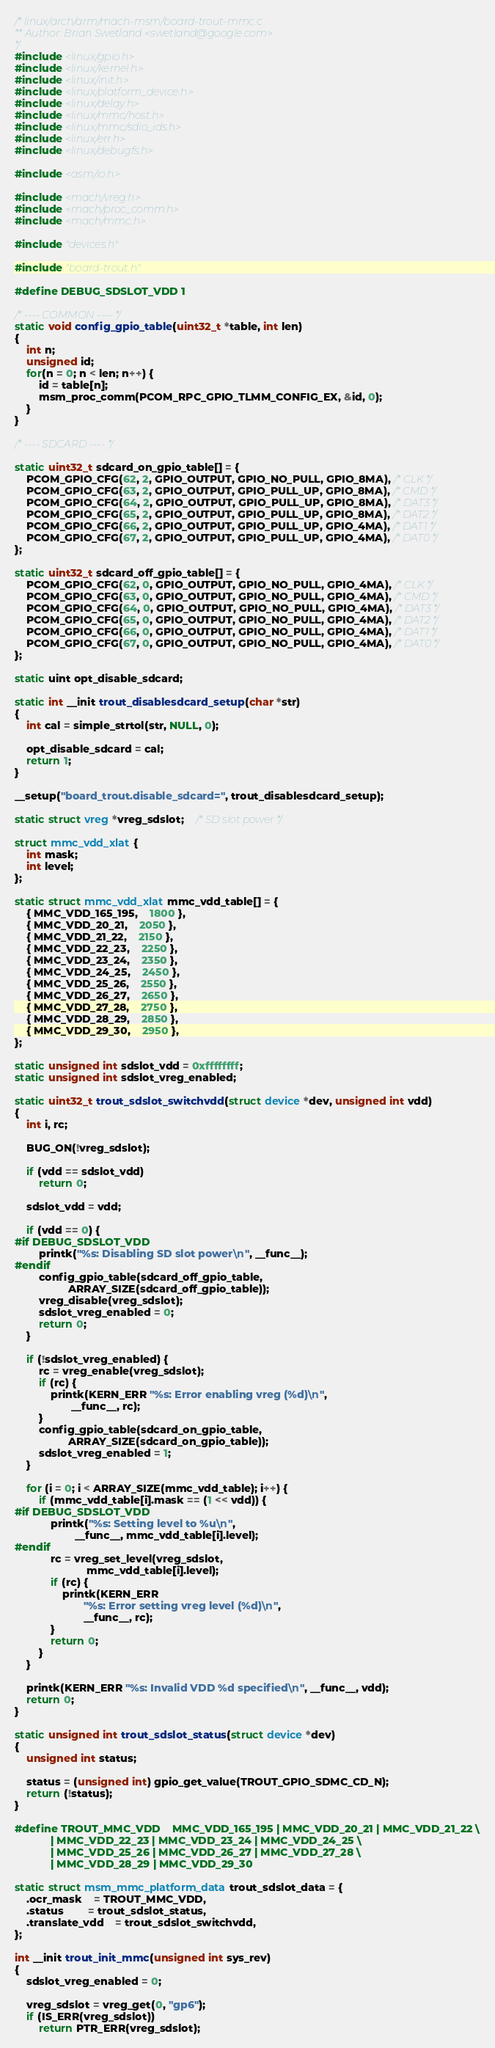Convert code to text. <code><loc_0><loc_0><loc_500><loc_500><_C_>/* linux/arch/arm/mach-msm/board-trout-mmc.c
** Author: Brian Swetland <swetland@google.com>
*/
#include <linux/gpio.h>
#include <linux/kernel.h>
#include <linux/init.h>
#include <linux/platform_device.h>
#include <linux/delay.h>
#include <linux/mmc/host.h>
#include <linux/mmc/sdio_ids.h>
#include <linux/err.h>
#include <linux/debugfs.h>

#include <asm/io.h>

#include <mach/vreg.h>
#include <mach/proc_comm.h>
#include <mach/mmc.h>

#include "devices.h"

#include "board-trout.h"

#define DEBUG_SDSLOT_VDD 1

/* ---- COMMON ---- */
static void config_gpio_table(uint32_t *table, int len)
{
	int n;
	unsigned id;
	for(n = 0; n < len; n++) {
		id = table[n];
		msm_proc_comm(PCOM_RPC_GPIO_TLMM_CONFIG_EX, &id, 0);
	}
}

/* ---- SDCARD ---- */

static uint32_t sdcard_on_gpio_table[] = {
	PCOM_GPIO_CFG(62, 2, GPIO_OUTPUT, GPIO_NO_PULL, GPIO_8MA), /* CLK */
	PCOM_GPIO_CFG(63, 2, GPIO_OUTPUT, GPIO_PULL_UP, GPIO_8MA), /* CMD */
	PCOM_GPIO_CFG(64, 2, GPIO_OUTPUT, GPIO_PULL_UP, GPIO_8MA), /* DAT3 */
	PCOM_GPIO_CFG(65, 2, GPIO_OUTPUT, GPIO_PULL_UP, GPIO_8MA), /* DAT2 */
	PCOM_GPIO_CFG(66, 2, GPIO_OUTPUT, GPIO_PULL_UP, GPIO_4MA), /* DAT1 */
	PCOM_GPIO_CFG(67, 2, GPIO_OUTPUT, GPIO_PULL_UP, GPIO_4MA), /* DAT0 */
};

static uint32_t sdcard_off_gpio_table[] = {
	PCOM_GPIO_CFG(62, 0, GPIO_OUTPUT, GPIO_NO_PULL, GPIO_4MA), /* CLK */
	PCOM_GPIO_CFG(63, 0, GPIO_OUTPUT, GPIO_NO_PULL, GPIO_4MA), /* CMD */
	PCOM_GPIO_CFG(64, 0, GPIO_OUTPUT, GPIO_NO_PULL, GPIO_4MA), /* DAT3 */
	PCOM_GPIO_CFG(65, 0, GPIO_OUTPUT, GPIO_NO_PULL, GPIO_4MA), /* DAT2 */
	PCOM_GPIO_CFG(66, 0, GPIO_OUTPUT, GPIO_NO_PULL, GPIO_4MA), /* DAT1 */
	PCOM_GPIO_CFG(67, 0, GPIO_OUTPUT, GPIO_NO_PULL, GPIO_4MA), /* DAT0 */
};

static uint opt_disable_sdcard;

static int __init trout_disablesdcard_setup(char *str)
{
	int cal = simple_strtol(str, NULL, 0);
	
	opt_disable_sdcard = cal;
	return 1;
}

__setup("board_trout.disable_sdcard=", trout_disablesdcard_setup);

static struct vreg *vreg_sdslot;	/* SD slot power */

struct mmc_vdd_xlat {
	int mask;
	int level;
};

static struct mmc_vdd_xlat mmc_vdd_table[] = {
	{ MMC_VDD_165_195,	1800 },
	{ MMC_VDD_20_21,	2050 },
	{ MMC_VDD_21_22,	2150 },
	{ MMC_VDD_22_23,	2250 },
	{ MMC_VDD_23_24,	2350 },
	{ MMC_VDD_24_25,	2450 },
	{ MMC_VDD_25_26,	2550 },
	{ MMC_VDD_26_27,	2650 },
	{ MMC_VDD_27_28,	2750 },
	{ MMC_VDD_28_29,	2850 },
	{ MMC_VDD_29_30,	2950 },
};

static unsigned int sdslot_vdd = 0xffffffff;
static unsigned int sdslot_vreg_enabled;

static uint32_t trout_sdslot_switchvdd(struct device *dev, unsigned int vdd)
{
	int i, rc;

	BUG_ON(!vreg_sdslot);

	if (vdd == sdslot_vdd)
		return 0;

	sdslot_vdd = vdd;

	if (vdd == 0) {
#if DEBUG_SDSLOT_VDD
		printk("%s: Disabling SD slot power\n", __func__);
#endif
		config_gpio_table(sdcard_off_gpio_table,
				  ARRAY_SIZE(sdcard_off_gpio_table));
		vreg_disable(vreg_sdslot);
		sdslot_vreg_enabled = 0;
		return 0;
	}

	if (!sdslot_vreg_enabled) {
		rc = vreg_enable(vreg_sdslot);
		if (rc) {
			printk(KERN_ERR "%s: Error enabling vreg (%d)\n",
			       __func__, rc);
		}
		config_gpio_table(sdcard_on_gpio_table,
				  ARRAY_SIZE(sdcard_on_gpio_table));
		sdslot_vreg_enabled = 1;
	}

	for (i = 0; i < ARRAY_SIZE(mmc_vdd_table); i++) {
		if (mmc_vdd_table[i].mask == (1 << vdd)) {
#if DEBUG_SDSLOT_VDD
			printk("%s: Setting level to %u\n",
			        __func__, mmc_vdd_table[i].level);
#endif
			rc = vreg_set_level(vreg_sdslot,
					    mmc_vdd_table[i].level);
			if (rc) {
				printk(KERN_ERR
				       "%s: Error setting vreg level (%d)\n",
				       __func__, rc);
			}
			return 0;
		}
	}

	printk(KERN_ERR "%s: Invalid VDD %d specified\n", __func__, vdd);
	return 0;
}

static unsigned int trout_sdslot_status(struct device *dev)
{
	unsigned int status;

	status = (unsigned int) gpio_get_value(TROUT_GPIO_SDMC_CD_N);
	return (!status);
}

#define TROUT_MMC_VDD	MMC_VDD_165_195 | MMC_VDD_20_21 | MMC_VDD_21_22 \
			| MMC_VDD_22_23 | MMC_VDD_23_24 | MMC_VDD_24_25 \
			| MMC_VDD_25_26 | MMC_VDD_26_27 | MMC_VDD_27_28 \
			| MMC_VDD_28_29 | MMC_VDD_29_30

static struct msm_mmc_platform_data trout_sdslot_data = {
	.ocr_mask	= TROUT_MMC_VDD,
	.status		= trout_sdslot_status,
	.translate_vdd	= trout_sdslot_switchvdd,
};

int __init trout_init_mmc(unsigned int sys_rev)
{
	sdslot_vreg_enabled = 0;

	vreg_sdslot = vreg_get(0, "gp6");
	if (IS_ERR(vreg_sdslot))
		return PTR_ERR(vreg_sdslot);
</code> 